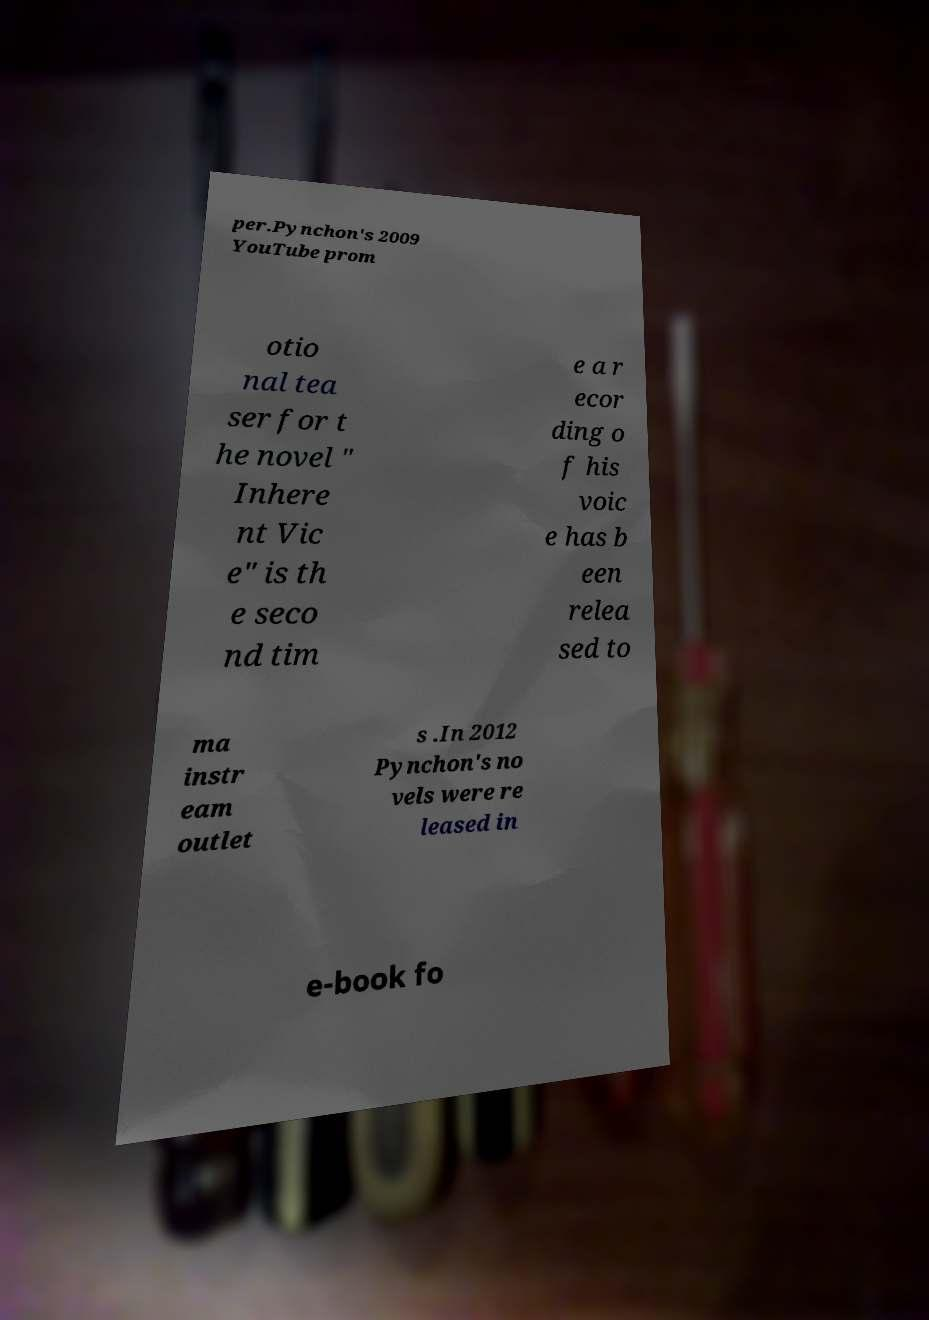I need the written content from this picture converted into text. Can you do that? per.Pynchon's 2009 YouTube prom otio nal tea ser for t he novel " Inhere nt Vic e" is th e seco nd tim e a r ecor ding o f his voic e has b een relea sed to ma instr eam outlet s .In 2012 Pynchon's no vels were re leased in e-book fo 